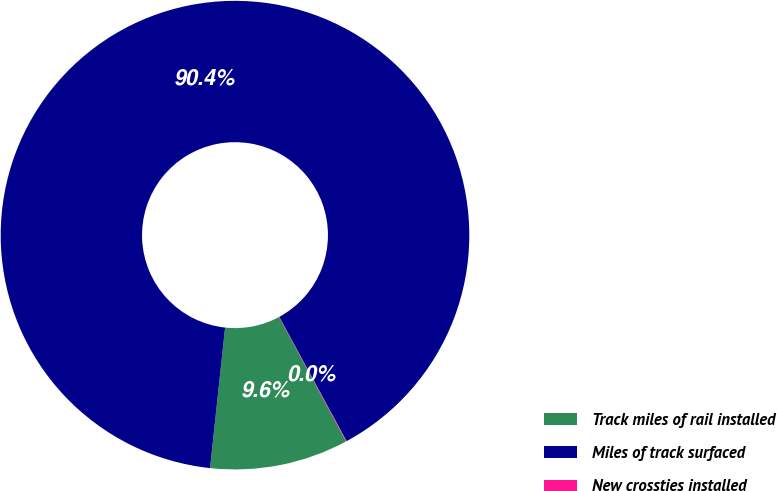<chart> <loc_0><loc_0><loc_500><loc_500><pie_chart><fcel>Track miles of rail installed<fcel>Miles of track surfaced<fcel>New crossties installed<nl><fcel>9.56%<fcel>90.4%<fcel>0.04%<nl></chart> 